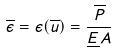Convert formula to latex. <formula><loc_0><loc_0><loc_500><loc_500>\overline { \epsilon } = \epsilon ( \overline { u } ) = \frac { \overline { P } } { \underline { E } A }</formula> 